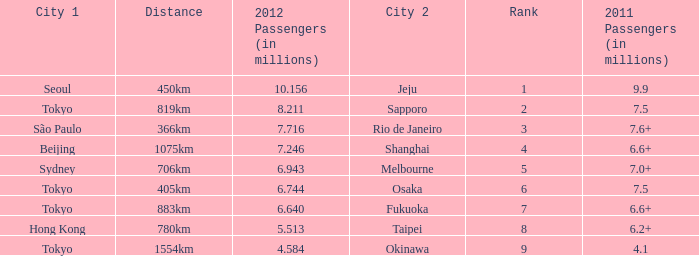How many passengers (in millions) in 2011 flew through along the route that had 6.640 million passengers in 2012? 6.6+. 